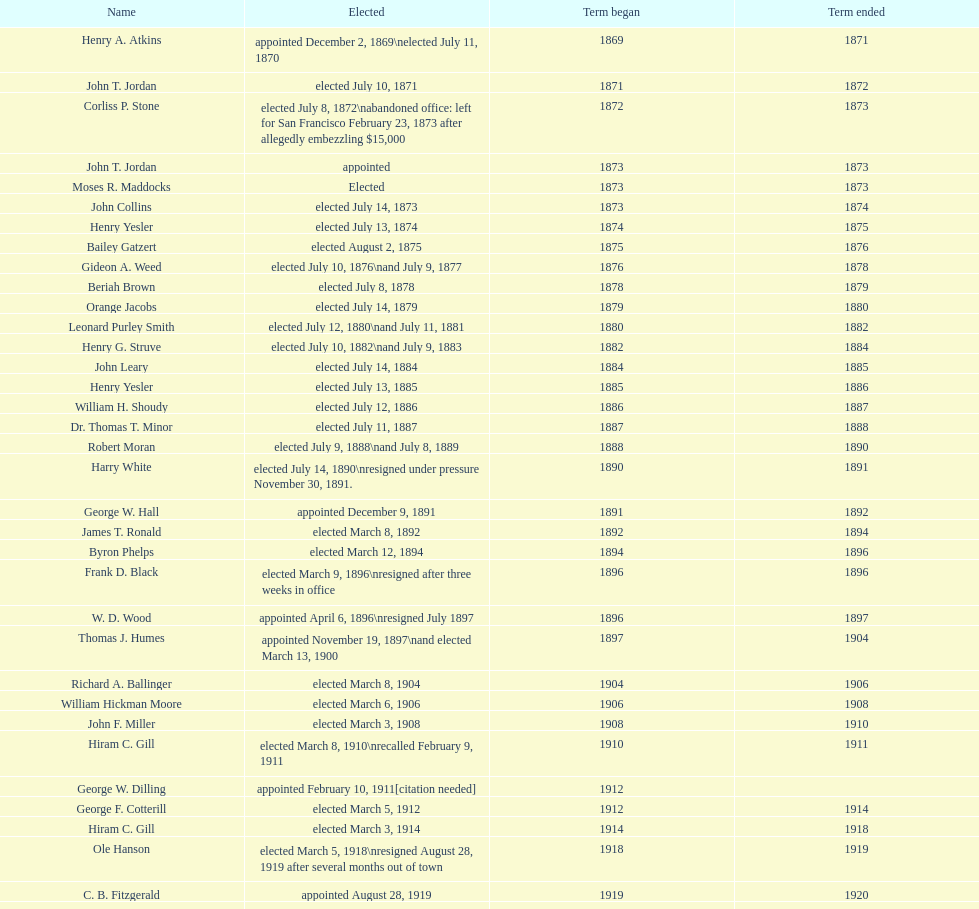Who occupied the role of mayor in seattle, washington before being designated to the department of transportation in the nixon administration? James d'Orma Braman. 